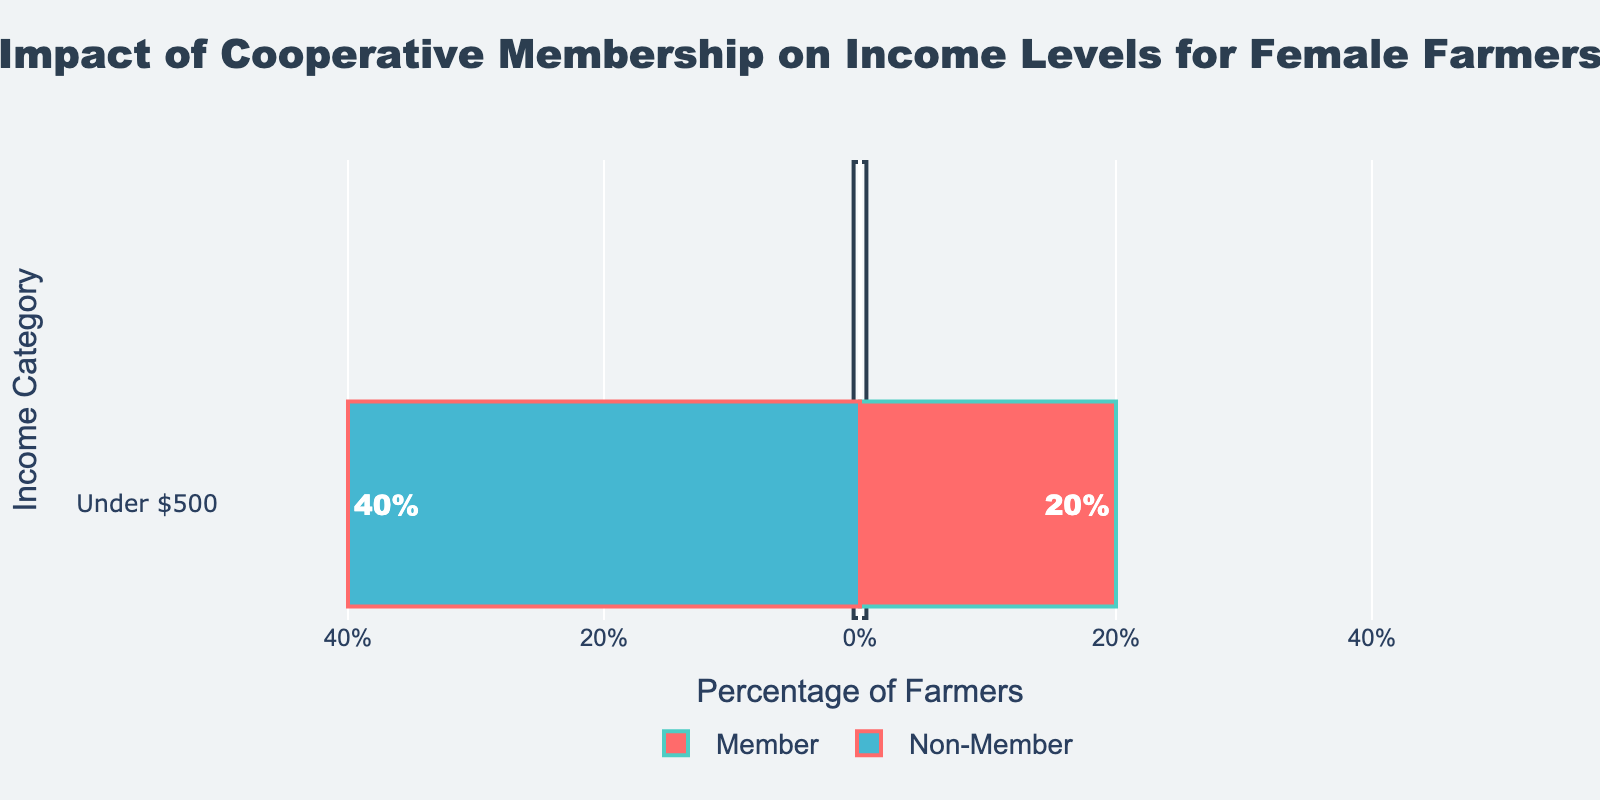How many non-member female farmers earn under $500? The "Non-Member" bar for the "Under $500" category is at 40%, indicating that 40% of non-member female farmers earn under $500.
Answer: 40% What is the difference in the proportion of female farmers earning under $500 between members and non-members? The "Member" bar is at 20% and the "Non-Member" bar is at 40%, so the difference is 40% - 20%.
Answer: 20% Which group has fewer female farmers earning under $500? The "Member" bar has a value of 20%, while the "Non-Member" bar has a value of 40%. Thus, members have a lower percentage.
Answer: Members By how much is the percentage of non-members earning under $500 greater than that of members? The percentage of non-members is 40%, and that of members is 20%. Subtract 20% from 40%.
Answer: 20% What percentage of female farmers earning under $500 are members of the cooperative? The "Member" bar indicates that 20% of female farmers who are cooperative members earn under $500.
Answer: 20% How many percentage points would the "Non-Member" bar need to decrease to equal the "Member" bar for the "Under $500" category? The "Non-Member" percentage is 40%, and the "Member" percentage is 20%. The difference is 40% - 20%.
Answer: 20% Identify the color used to represent the non-member female farmers. The bar for non-members is represented by a blue color.
Answer: Blue If the percentage of non-members earning under $500 decreases by 10%, what would be the new percentage? The current percentage for non-members is 40%. Subtracting 10% from 40% gives the new percentage.
Answer: 30% What is the sum of the percentages of members and non-members earning under $500? The percentages are 20% for members and 40% for non-members. Adding these together gives 20% + 40%.
Answer: 60% By what fraction is the proportion of non-member female farmers earning under $500 larger than that of members? The non-member percentage (40%) divided by the member percentage (20%) is 40/20, simplifying to 2.
Answer: 2 